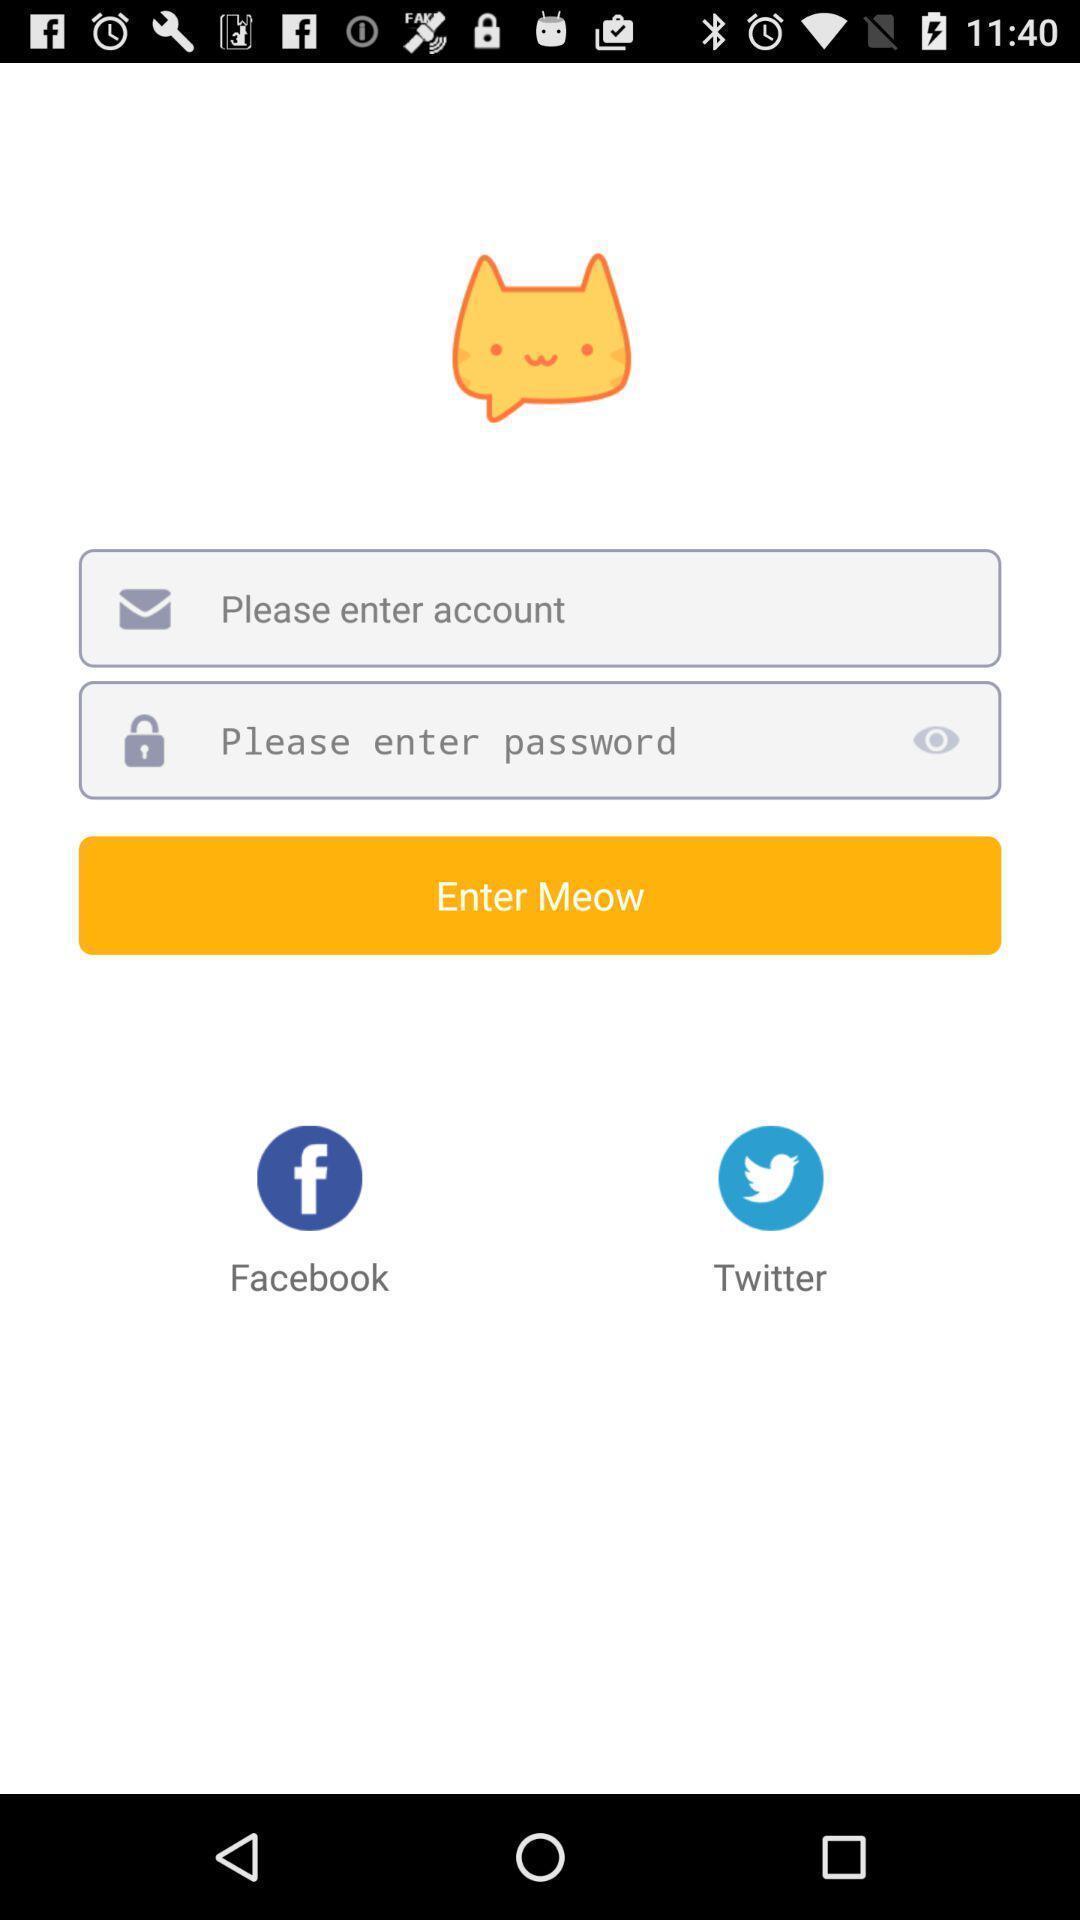Summarize the main components in this picture. Sign in page. 